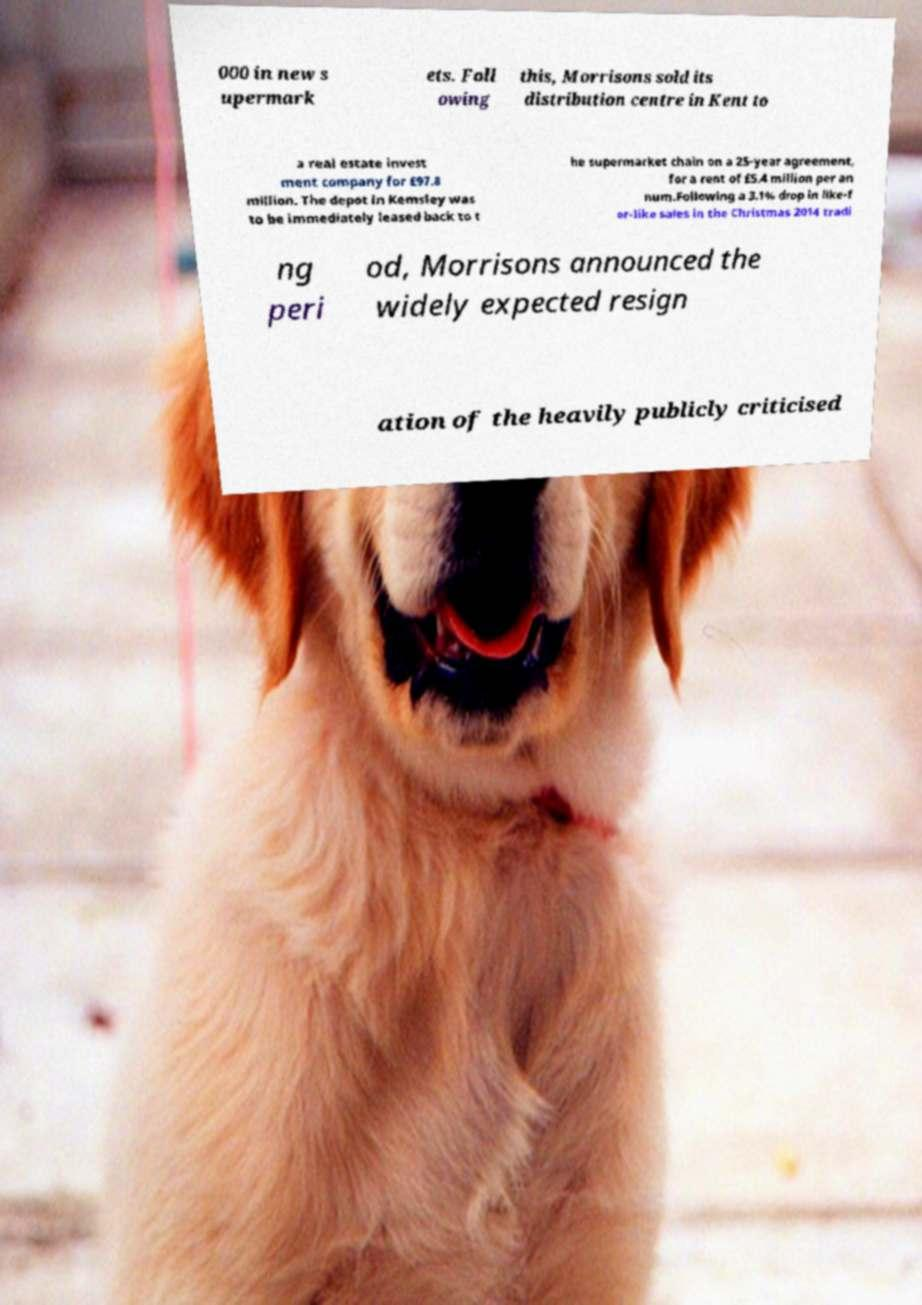Can you accurately transcribe the text from the provided image for me? 000 in new s upermark ets. Foll owing this, Morrisons sold its distribution centre in Kent to a real estate invest ment company for £97.8 million. The depot in Kemsley was to be immediately leased back to t he supermarket chain on a 25-year agreement, for a rent of £5.4 million per an num.Following a 3.1% drop in like-f or-like sales in the Christmas 2014 tradi ng peri od, Morrisons announced the widely expected resign ation of the heavily publicly criticised 